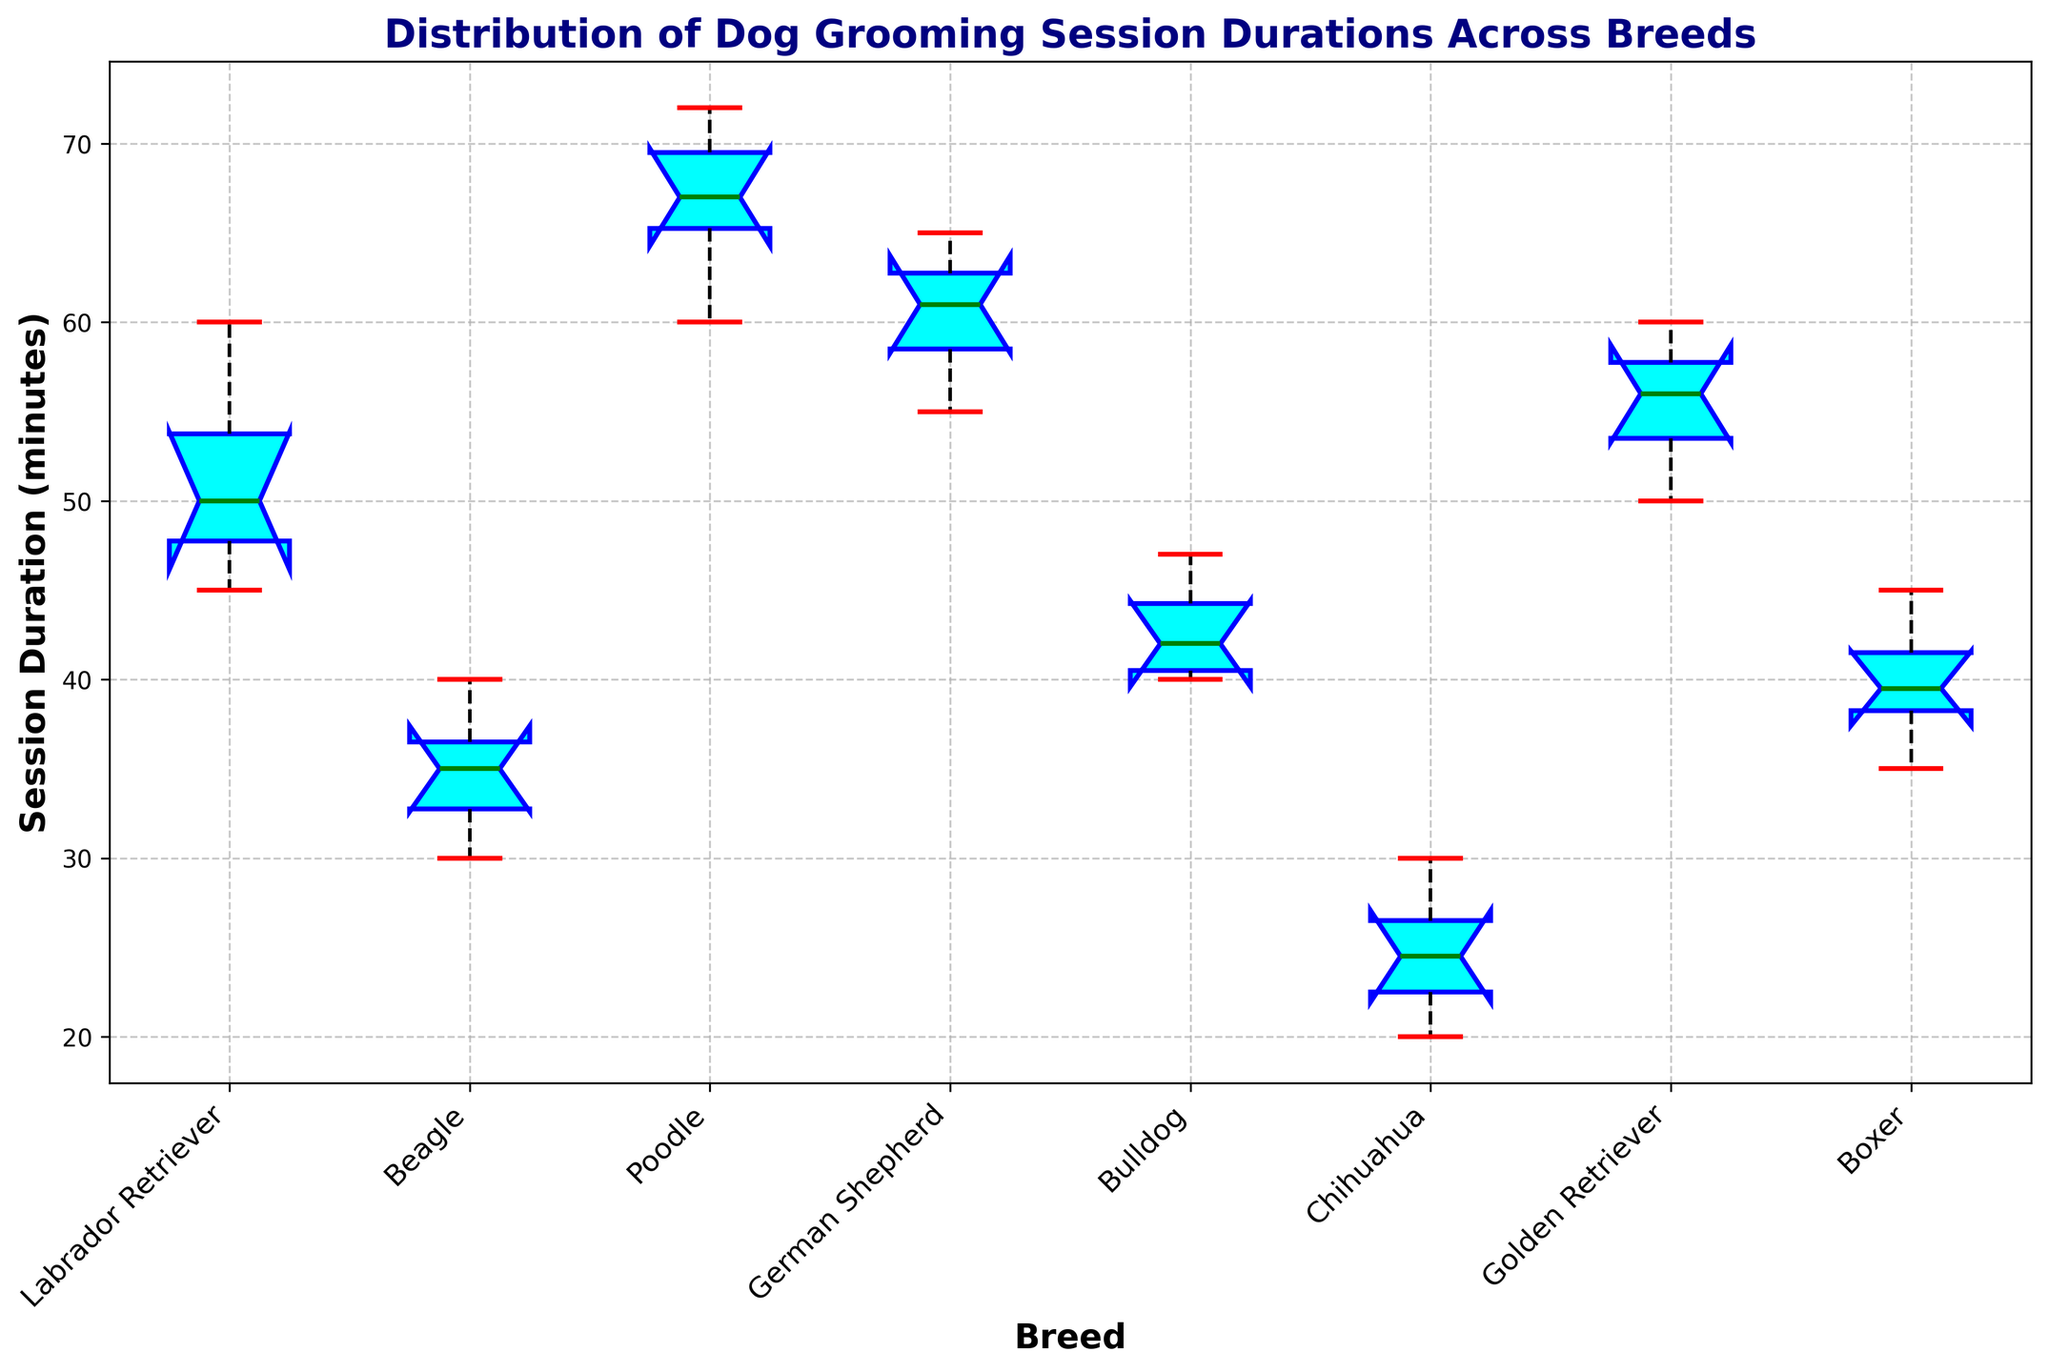What breed has the longest median grooming session duration? Look for the breed with the highest line in the center of the box representing the median value.
Answer: Poodle Which breed has the widest interquartile range (IQR) for grooming session durations? The IQR is the range between the lower (25th percentile) and upper (75th percentile) quartiles. Identify the breed with the largest box height.
Answer: German Shepherd Compare the median grooming session durations between Golden Retriever and Boxer. Which is higher? Compare the central lines of the boxes for Golden Retriever and Boxer.
Answer: Golden Retriever What is the approximate range of grooming session durations for Chihuahua? Look at the length between the ends of the whiskers for Chihuahuas.
Answer: 20 to 30 minutes Are there any outliers in the grooming session durations for Bulldogs? Identify if there are any individual points outside the whiskers for Bulldogs.
Answer: No Which breed's grooming sessions show the least variability? The breed with the smallest box and shortest whiskers shows the least variability.
Answer: Beagle Calculate the approximate average of the medians for Labrador Retriever and Poodle. The medians are around 50 for Labrador Retriever and 68 for Poodle. Average = (50 + 68) / 2.
Answer: 59 Which breeds have distinctly different median grooming session durations? Look for breeds with non-overlapping notches around the median lines.
Answer: Labrador Retriever and Chihuahua Compare the whisker lengths of Beagle and Poodle. Which breed has longer whiskers? Compare the lengths of the lines extending from the boxes.
Answer: Poodle If you were to rank breeds by their median grooming session durations from least to greatest, which rank would the Chihuahua have? Rank the breeds' median values visually from least to greatest using the central lines.
Answer: 1st 